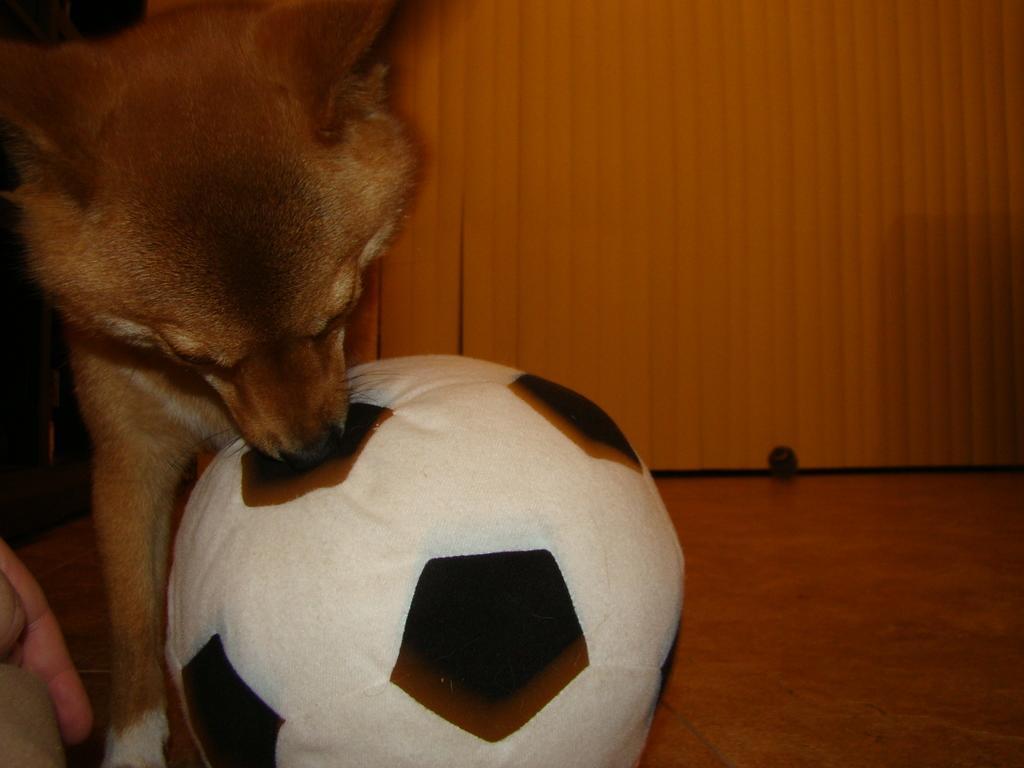Could you give a brief overview of what you see in this image? Here we can see a dog on the floor and we can see ball. Background it is orange. 